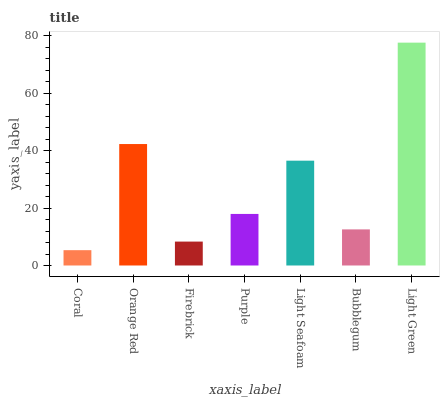Is Coral the minimum?
Answer yes or no. Yes. Is Light Green the maximum?
Answer yes or no. Yes. Is Orange Red the minimum?
Answer yes or no. No. Is Orange Red the maximum?
Answer yes or no. No. Is Orange Red greater than Coral?
Answer yes or no. Yes. Is Coral less than Orange Red?
Answer yes or no. Yes. Is Coral greater than Orange Red?
Answer yes or no. No. Is Orange Red less than Coral?
Answer yes or no. No. Is Purple the high median?
Answer yes or no. Yes. Is Purple the low median?
Answer yes or no. Yes. Is Coral the high median?
Answer yes or no. No. Is Light Seafoam the low median?
Answer yes or no. No. 